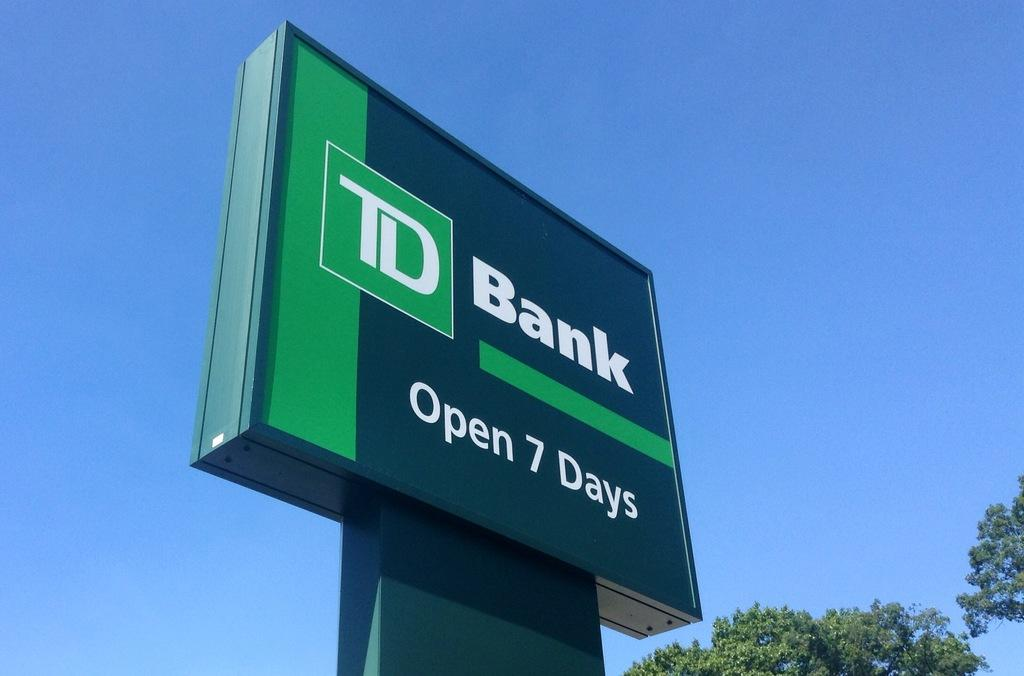<image>
Describe the image concisely. The hours of operation at TD Bank span all seven days of the week. 